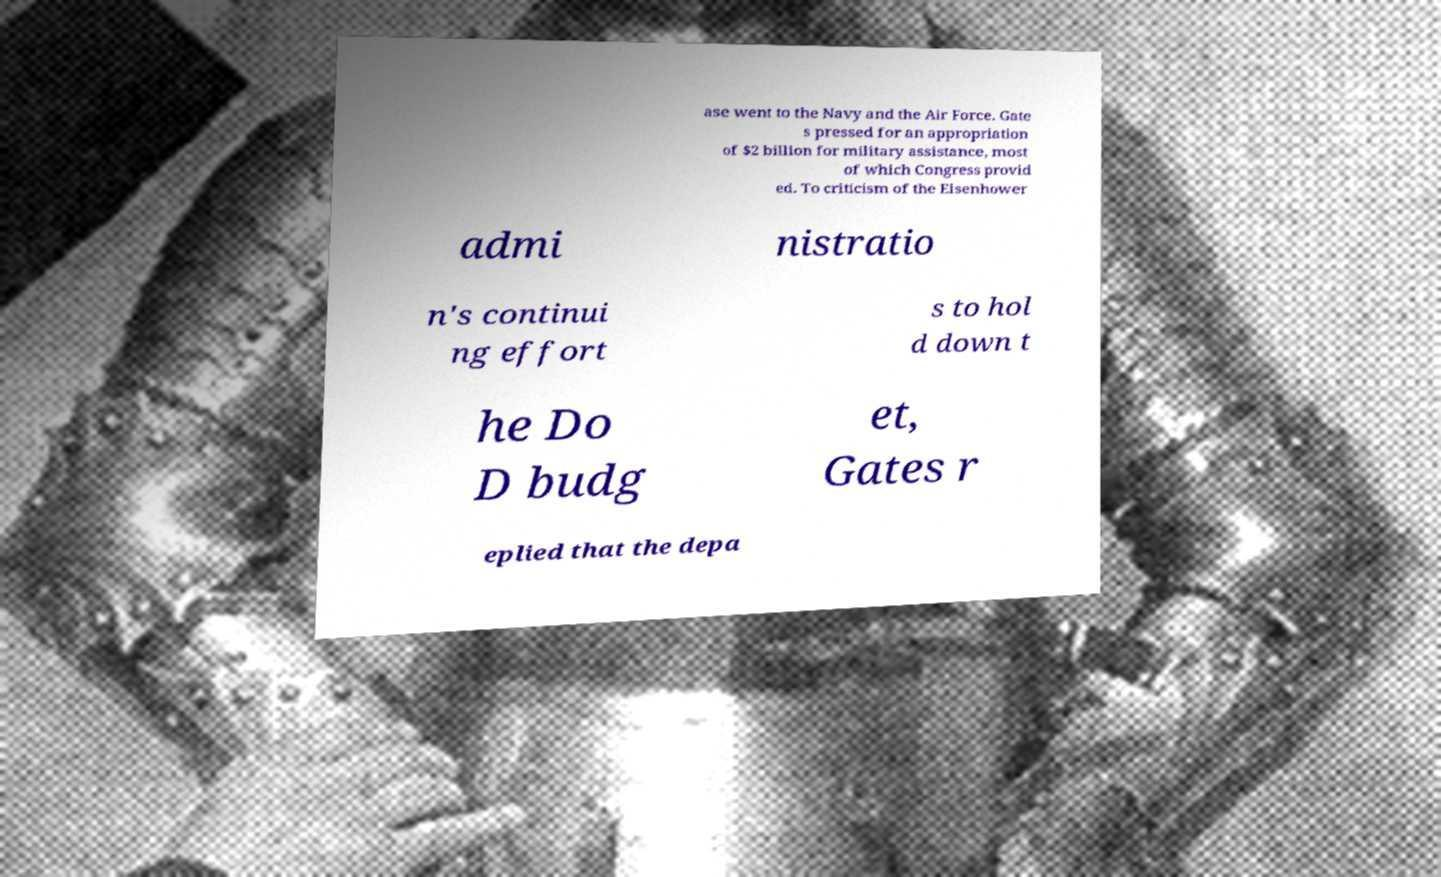Please identify and transcribe the text found in this image. ase went to the Navy and the Air Force. Gate s pressed for an appropriation of $2 billion for military assistance, most of which Congress provid ed. To criticism of the Eisenhower admi nistratio n's continui ng effort s to hol d down t he Do D budg et, Gates r eplied that the depa 